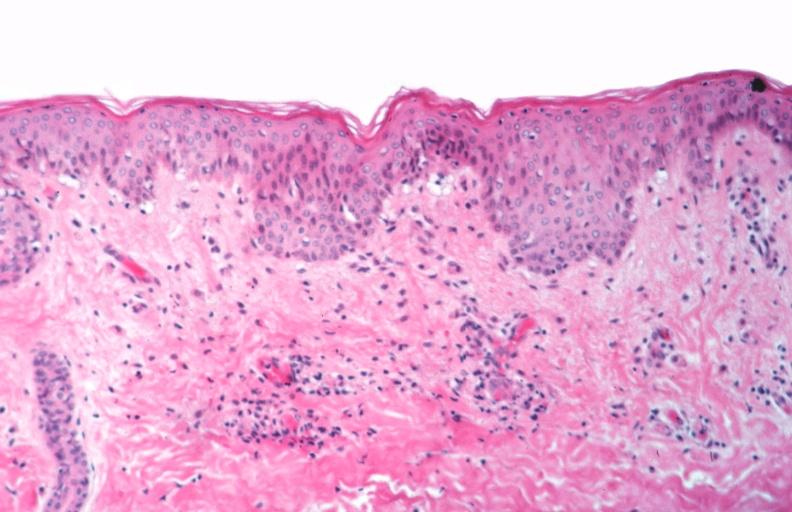what does this image show?
Answer the question using a single word or phrase. Skin 